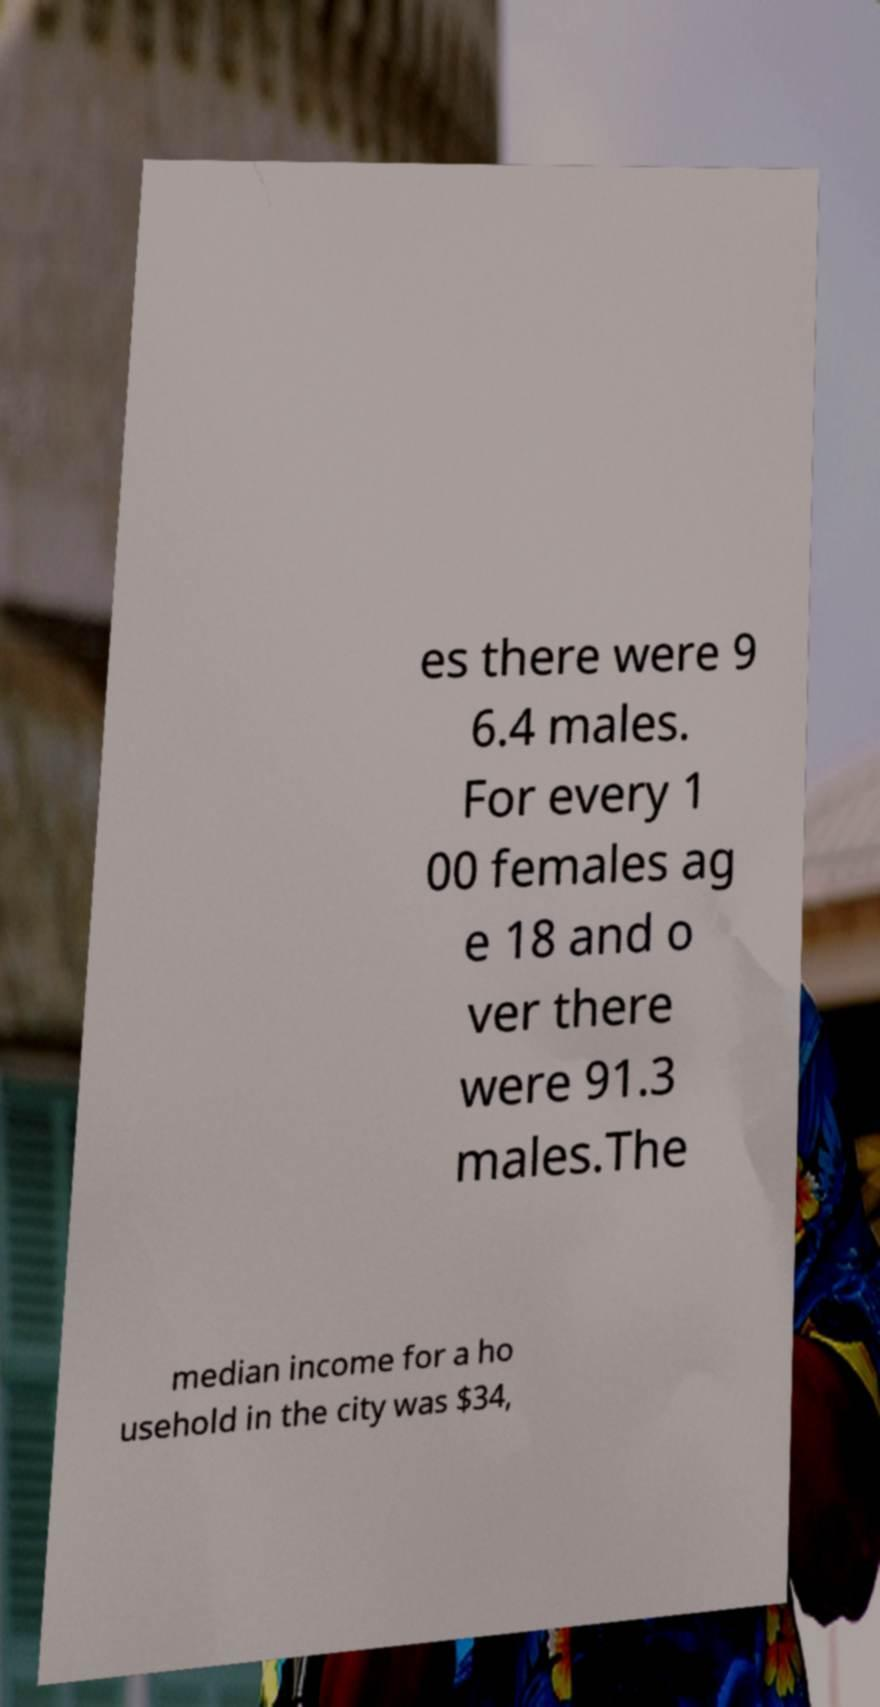For documentation purposes, I need the text within this image transcribed. Could you provide that? es there were 9 6.4 males. For every 1 00 females ag e 18 and o ver there were 91.3 males.The median income for a ho usehold in the city was $34, 